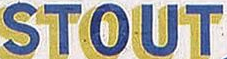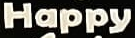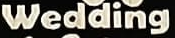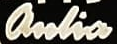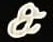What text is displayed in these images sequentially, separated by a semicolon? STOUT; Happy; Wedding; anlia; & 